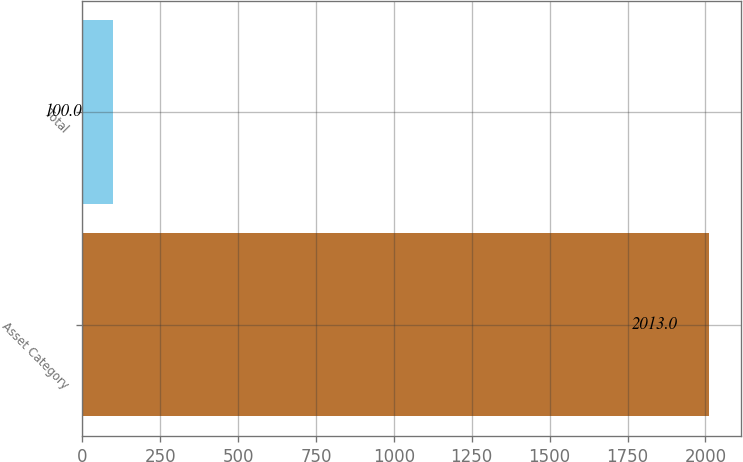<chart> <loc_0><loc_0><loc_500><loc_500><bar_chart><fcel>Asset Category<fcel>Total<nl><fcel>2013<fcel>100<nl></chart> 